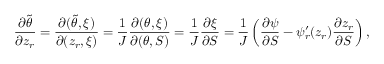<formula> <loc_0><loc_0><loc_500><loc_500>\frac { \partial \tilde { \theta } } { \partial z _ { r } } = \frac { \partial ( \tilde { \theta } , \xi ) } { \partial ( z _ { r } , \xi ) } = \frac { 1 } { J } \frac { \partial ( \theta , \xi ) } { \partial ( \theta , S ) } = \frac { 1 } { J } \frac { \partial \xi } { \partial S } = \frac { 1 } { J } \left ( \frac { \partial \psi } { \partial S } - \psi _ { r } ^ { \prime } ( z _ { r } ) \frac { \partial z _ { r } } { \partial S } \right ) ,</formula> 